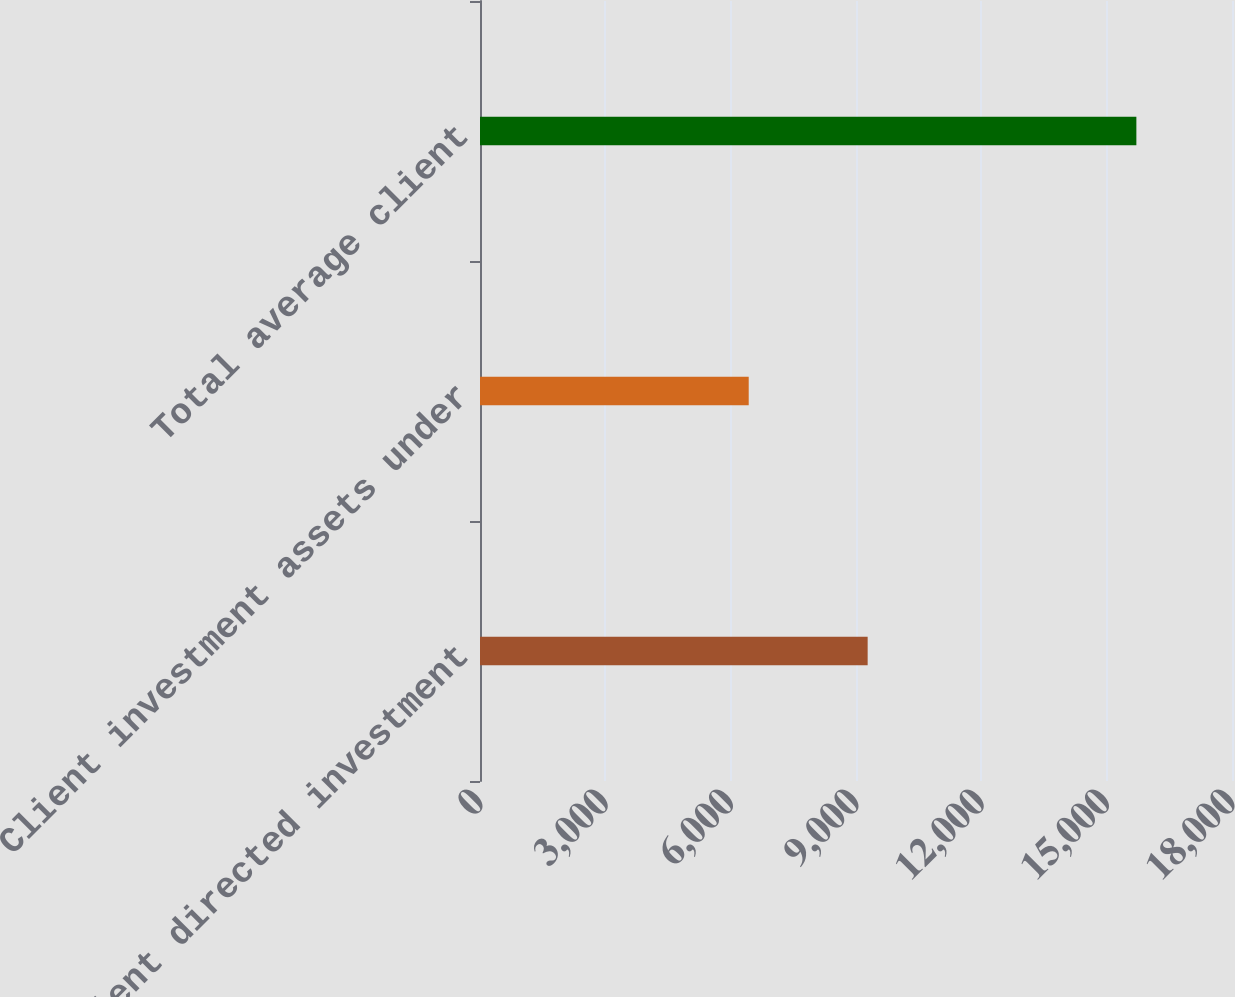<chart> <loc_0><loc_0><loc_500><loc_500><bar_chart><fcel>Client directed investment<fcel>Client investment assets under<fcel>Total average client<nl><fcel>9279<fcel>6432<fcel>15711<nl></chart> 